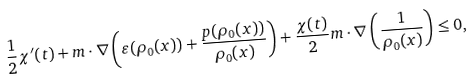Convert formula to latex. <formula><loc_0><loc_0><loc_500><loc_500>\frac { 1 } { 2 } \chi ^ { \prime } ( t ) + m \cdot \nabla \left ( \varepsilon ( \rho _ { 0 } ( x ) ) + \frac { p ( \rho _ { 0 } ( x ) ) } { \rho _ { 0 } ( x ) } \right ) + \frac { \chi ( t ) } { 2 } m \cdot \nabla \left ( \frac { 1 } { \rho _ { 0 } ( x ) } \right ) \leq 0 ,</formula> 